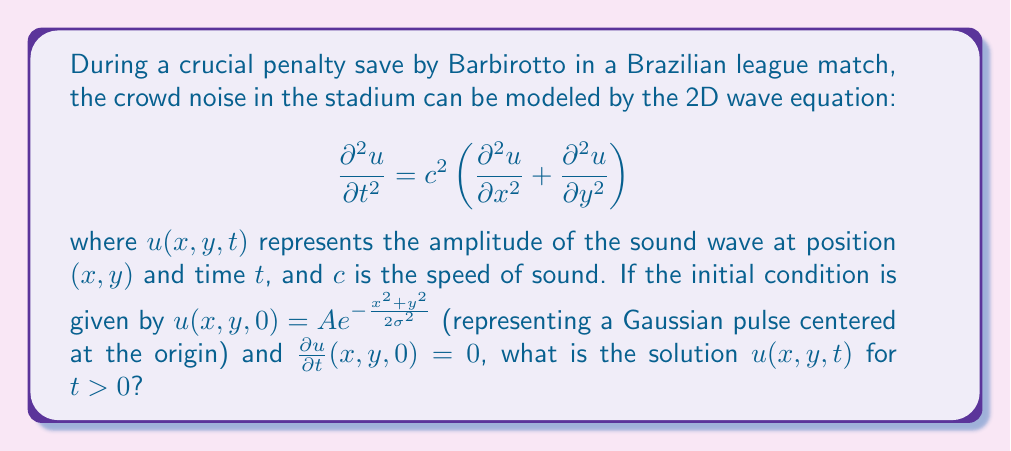Can you solve this math problem? To solve this problem, we'll follow these steps:

1) The general solution for the 2D wave equation with radial symmetry is given by:

   $$u(r,t) = \frac{1}{2\pi c^2t} \int_0^{2\pi} \int_0^{ct} f(r')r' d\theta dr'$$

   where $r = \sqrt{x^2 + y^2}$ and $f(r)$ is the initial condition.

2) In our case, $f(r) = A e^{-\frac{r^2}{2\sigma^2}}$

3) Substituting this into the general solution:

   $$u(r,t) = \frac{A}{2\pi c^2t} \int_0^{2\pi} \int_0^{ct} e^{-\frac{r'^2}{2\sigma^2}}r' d\theta dr'$$

4) The $\theta$ integral is simply $2\pi$, so we have:

   $$u(r,t) = \frac{A}{c^2t} \int_0^{ct} e^{-\frac{r'^2}{2\sigma^2}}r' dr'$$

5) This integral can be solved using the substitution $u = \frac{r'^2}{2\sigma^2}$:

   $$u(r,t) = \frac{A\sigma^2}{c^2t} \left[1 - e^{-\frac{c^2t^2}{2\sigma^2}}\right]$$

6) To express this in terms of $x$ and $y$, we replace $r$ with $\sqrt{x^2 + y^2}$:

   $$u(x,y,t) = \frac{A\sigma^2}{c^2t} \left[1 - e^{-\frac{c^2t^2}{2\sigma^2}}\right]$$

This is the solution for $t > 0$. Note that it satisfies the initial conditions:
- At $t = 0^+$, $u(x,y,0^+) = A e^{-\frac{x^2+y^2}{2\sigma^2}}$
- $\frac{\partial u}{\partial t}(x,y,0) = 0$
Answer: $$u(x,y,t) = \frac{A\sigma^2}{c^2t} \left[1 - e^{-\frac{c^2t^2}{2\sigma^2}}\right]$$ 